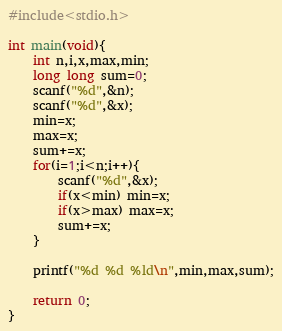<code> <loc_0><loc_0><loc_500><loc_500><_C_>#include<stdio.h>

int main(void){
    int n,i,x,max,min;
    long long sum=0;
    scanf("%d",&n);
    scanf("%d",&x);
    min=x;
    max=x;
    sum+=x;
    for(i=1;i<n;i++){
        scanf("%d",&x);
        if(x<min) min=x;
        if(x>max) max=x;
        sum+=x;
    }
    
    printf("%d %d %ld\n",min,max,sum);
    
    return 0;
}
</code> 